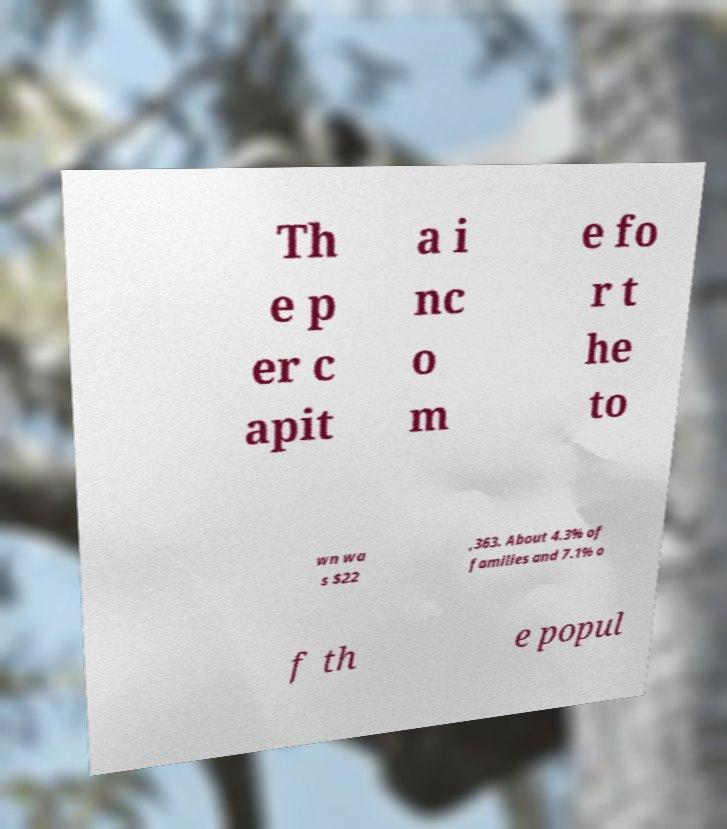Please read and relay the text visible in this image. What does it say? Th e p er c apit a i nc o m e fo r t he to wn wa s $22 ,363. About 4.3% of families and 7.1% o f th e popul 